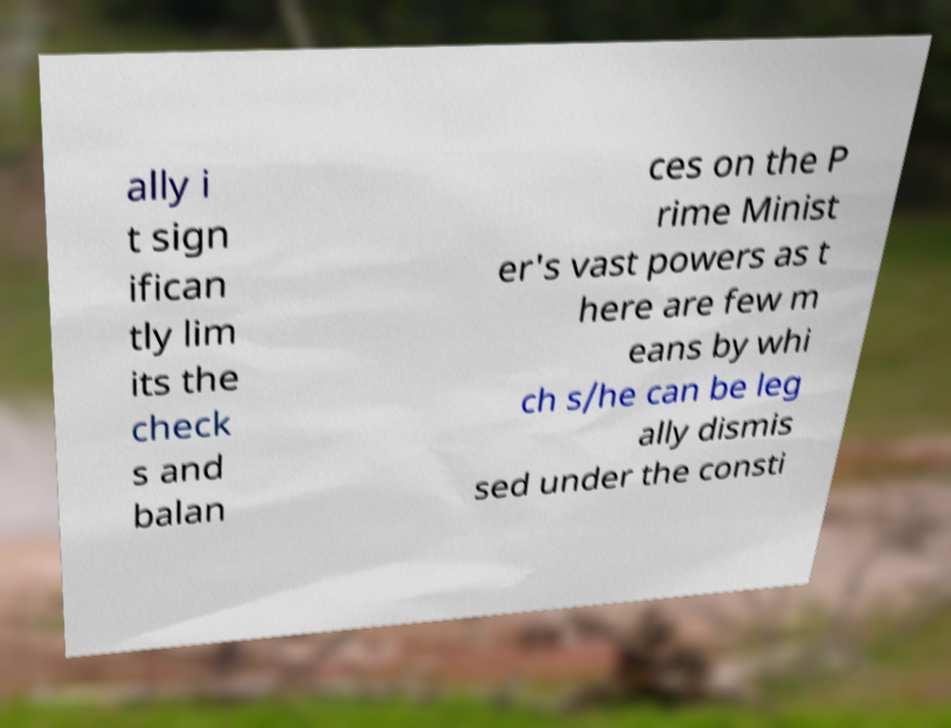For documentation purposes, I need the text within this image transcribed. Could you provide that? ally i t sign ifican tly lim its the check s and balan ces on the P rime Minist er's vast powers as t here are few m eans by whi ch s/he can be leg ally dismis sed under the consti 